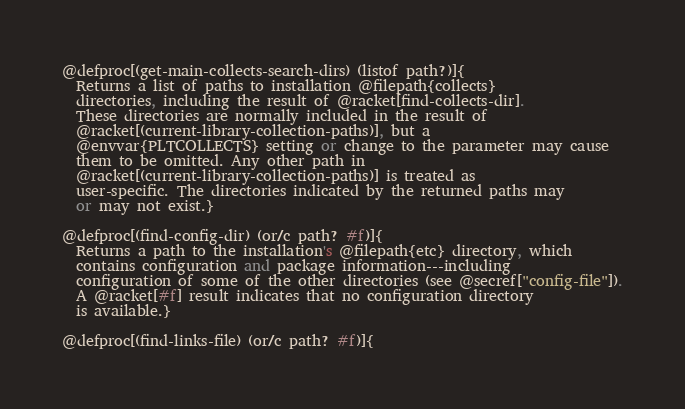<code> <loc_0><loc_0><loc_500><loc_500><_Racket_>
@defproc[(get-main-collects-search-dirs) (listof path?)]{
  Returns a list of paths to installation @filepath{collects}
  directories, including the result of @racket[find-collects-dir].
  These directories are normally included in the result of
  @racket[(current-library-collection-paths)], but a
  @envvar{PLTCOLLECTS} setting or change to the parameter may cause
  them to be omitted. Any other path in
  @racket[(current-library-collection-paths)] is treated as
  user-specific. The directories indicated by the returned paths may
  or may not exist.}

@defproc[(find-config-dir) (or/c path? #f)]{
  Returns a path to the installation's @filepath{etc} directory, which
  contains configuration and package information---including
  configuration of some of the other directories (see @secref["config-file"]).
  A @racket[#f] result indicates that no configuration directory
  is available.}

@defproc[(find-links-file) (or/c path? #f)]{</code> 